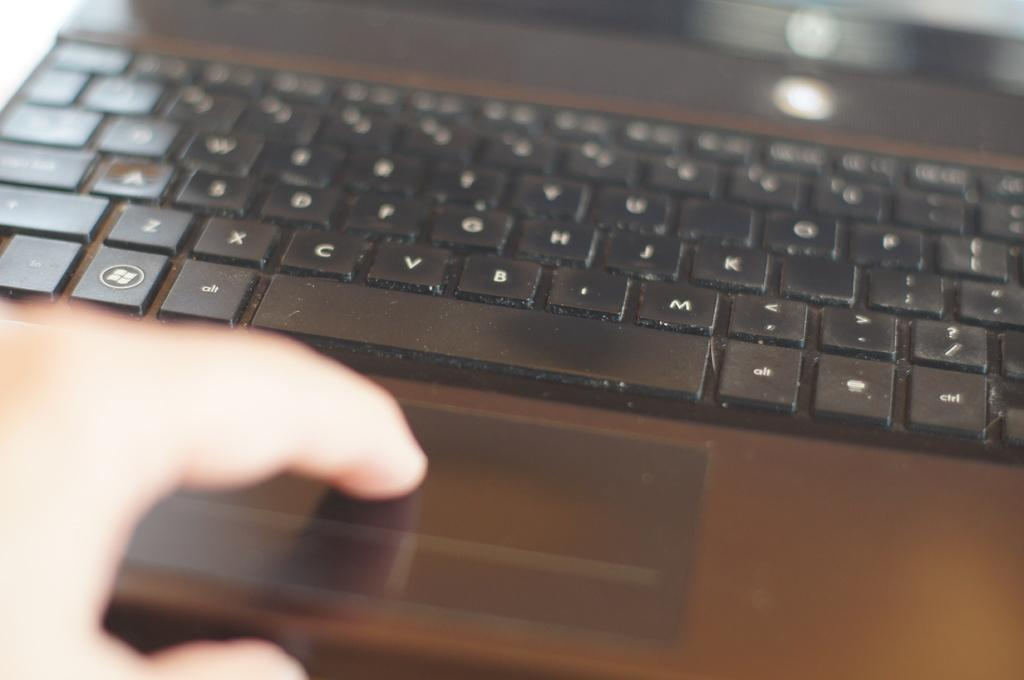<image>
Share a concise interpretation of the image provided. A black keyboard shows a windows button next to the alt button 